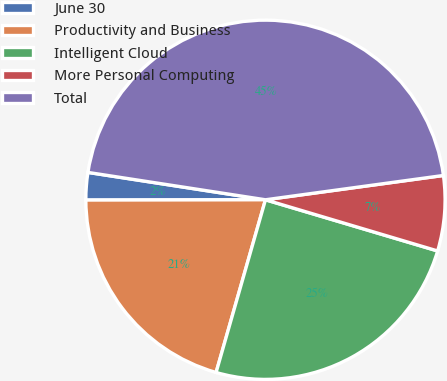<chart> <loc_0><loc_0><loc_500><loc_500><pie_chart><fcel>June 30<fcel>Productivity and Business<fcel>Intelligent Cloud<fcel>More Personal Computing<fcel>Total<nl><fcel>2.46%<fcel>20.54%<fcel>24.83%<fcel>6.76%<fcel>45.4%<nl></chart> 